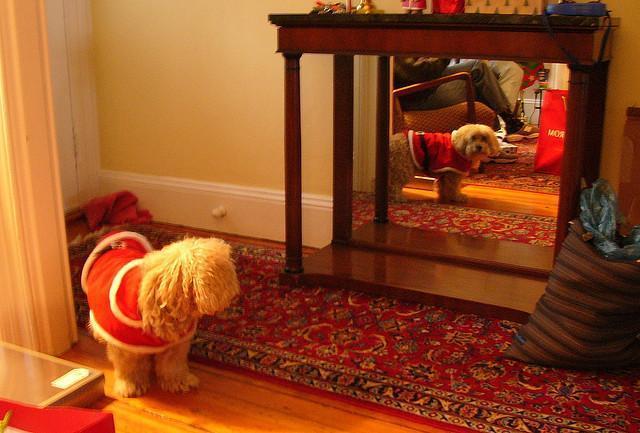How many people are there?
Give a very brief answer. 1. How many kinds of donuts are shown?
Give a very brief answer. 0. 